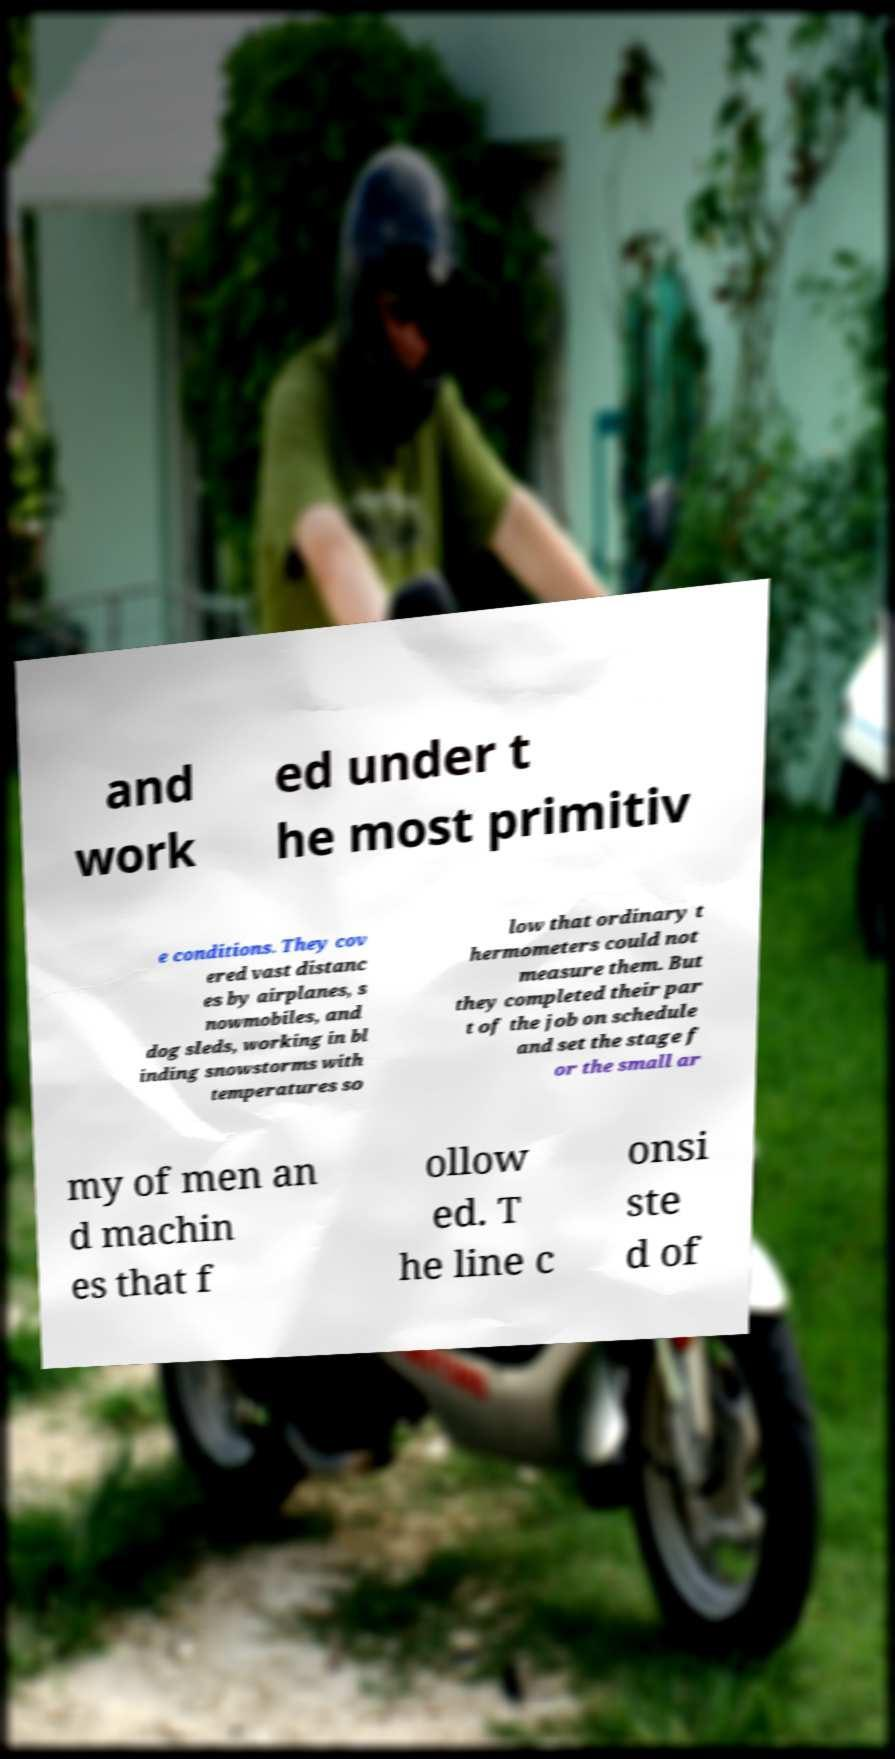For documentation purposes, I need the text within this image transcribed. Could you provide that? and work ed under t he most primitiv e conditions. They cov ered vast distanc es by airplanes, s nowmobiles, and dog sleds, working in bl inding snowstorms with temperatures so low that ordinary t hermometers could not measure them. But they completed their par t of the job on schedule and set the stage f or the small ar my of men an d machin es that f ollow ed. T he line c onsi ste d of 